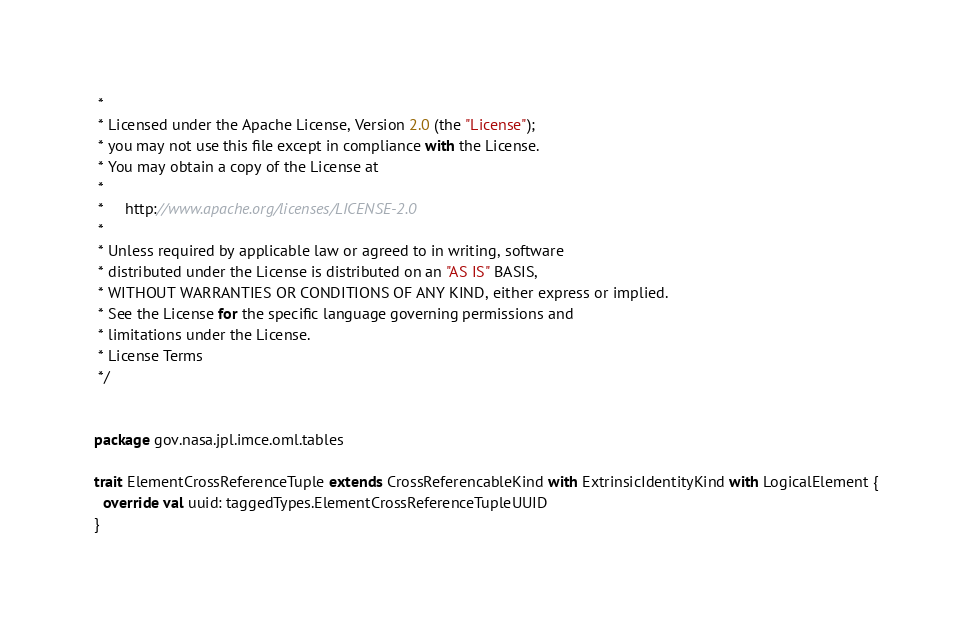<code> <loc_0><loc_0><loc_500><loc_500><_Scala_> *
 * Licensed under the Apache License, Version 2.0 (the "License");
 * you may not use this file except in compliance with the License.
 * You may obtain a copy of the License at
 *
 *     http://www.apache.org/licenses/LICENSE-2.0
 *
 * Unless required by applicable law or agreed to in writing, software
 * distributed under the License is distributed on an "AS IS" BASIS,
 * WITHOUT WARRANTIES OR CONDITIONS OF ANY KIND, either express or implied.
 * See the License for the specific language governing permissions and
 * limitations under the License.
 * License Terms
 */

 
package gov.nasa.jpl.imce.oml.tables

trait ElementCrossReferenceTuple extends CrossReferencableKind with ExtrinsicIdentityKind with LogicalElement {
  override val uuid: taggedTypes.ElementCrossReferenceTupleUUID
}
</code> 